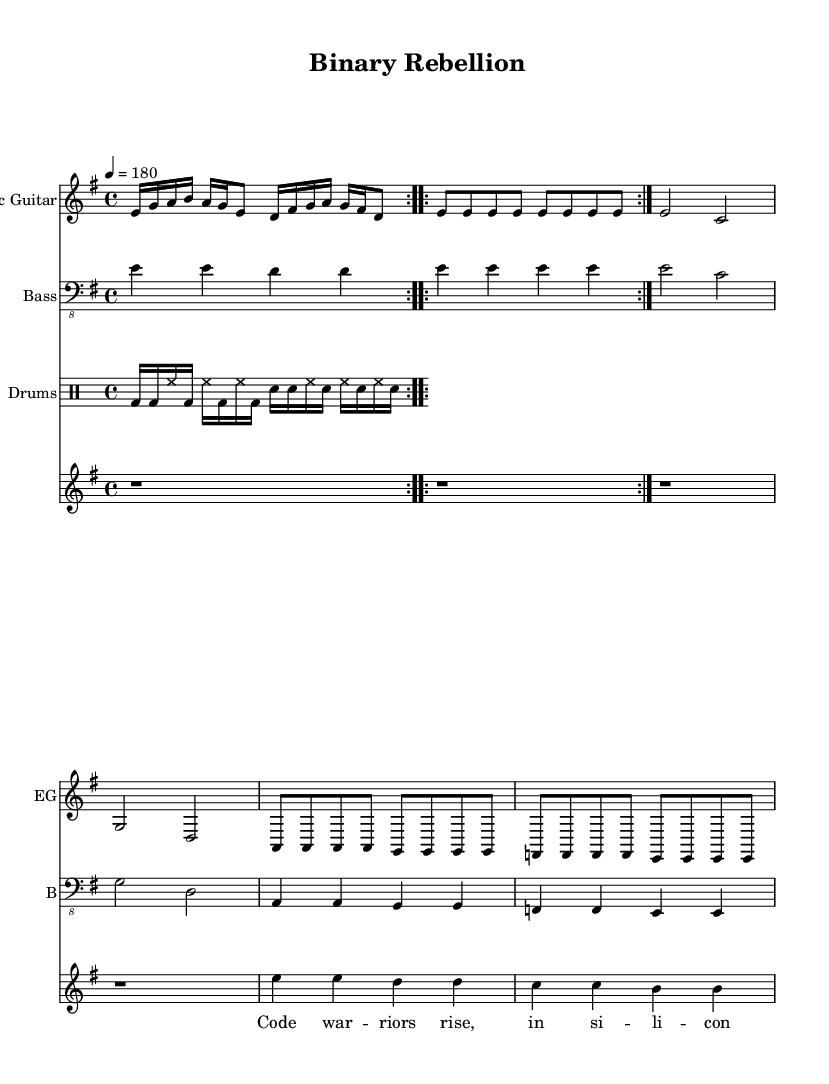What is the key signature of this music? The key signature is indicated at the beginning of the staff. Here, it shows one sharp, indicating that this piece is in E minor.
Answer: E minor What is the time signature of this music? The time signature is found at the beginning of the score. It shows four beats per measure, which is represented by the 4/4 notation.
Answer: 4/4 What is the tempo marking of this piece? The tempo marking indicates how fast the music should be played. It is specified at the start with a number (180), meaning beats per minute (BPM).
Answer: 180 Which instrument has the main riff? The main riff is typically associated with the electric guitar part, as it plays the most prominent and melodic lines in this section.
Answer: Electric Guitar How many measures are there in the verse part? To find this, you count the number of times the verse section is repeated and the number of measures in that section. Each time the verse is repeated consists of eight measures, repeated twice, resulting in 16 measures total.
Answer: 16 What is the primary theme of the lyrics? The lyrics address the competitive environment of tech startups and the challenges within that industry, which can be inferred from phrases like "code war" and "status quo."
Answer: Competitive tech startups Which section follows after the verse in the song structure? The song structure sequence can be identified by looking at how the sections are arranged. After the verse, the next section explicitly noted is the chorus.
Answer: Chorus 